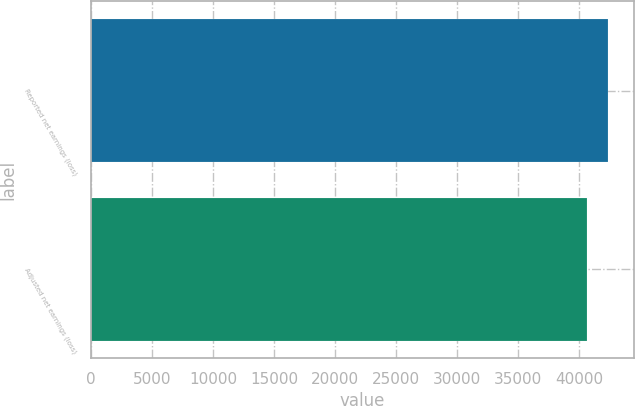Convert chart. <chart><loc_0><loc_0><loc_500><loc_500><bar_chart><fcel>Reported net earnings (loss)<fcel>Adjusted net earnings (loss)<nl><fcel>42366<fcel>40608<nl></chart> 